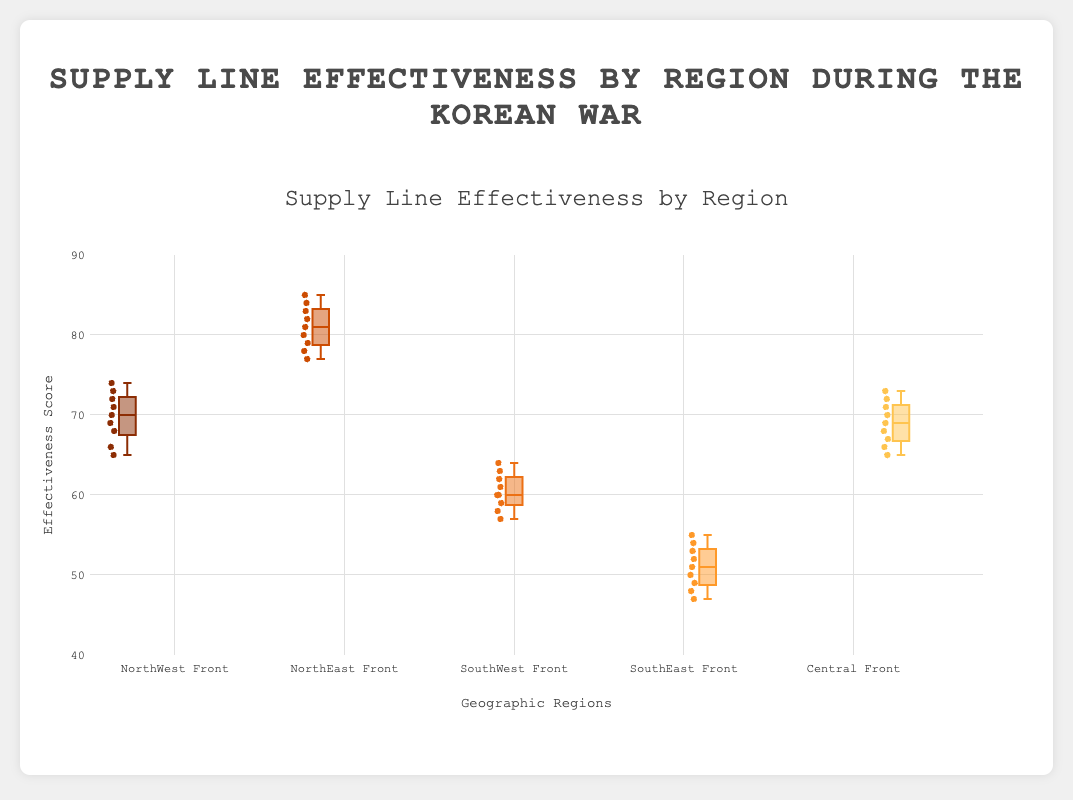What does the title of the figure indicate? The title of the figure "Supply Line Effectiveness by Region during the Korean War" indicates that the plot shows how effective the supply lines were across different geographic regions during the Korean War.
Answer: Supply Line Effectiveness by Region during the Korean War What is the range of the y-axis? The y-axis is labeled "Effectiveness Score" and ranges from 40 to 90. This range encompasses the possible effectiveness scores depicted in the box plots.
Answer: 40 to 90 Which region has the highest median supply line effectiveness? To determine which region has the highest median effectiveness, identify the horizontal line within each box representing the median. The NorthEast_Front has the highest median line of all regions.
Answer: NorthEast Front Which region has the lowest maximum supply line effectiveness? Identify the highest points, or "whiskers," of each box plot to find the maximum effectiveness for each region. The SouthEast_Front has the lowest maximum effectiveness.
Answer: SouthEast Front How does the interquartile range (IQR) compare between the NorthWest_Front and the SouthEast_Front? The IQR is the difference between the upper quartile and the lower quartile, represented by the top and bottom of the box. Comparing these, the NorthWest_Front has a much smaller IQR compared to the SouthEast_Front. The NorthWest_Front appears more consistent than the SouthEast_Front.
Answer: NorthWest Front has a smaller IQR Which region shows the greatest variability in supply line effectiveness? The region with the longest box, indicating the IQR, and possibly longer whiskers represent the greatest variability. The SouthEast_Front shows the greatest variability in effectiveness scores.
Answer: SouthEast Front What is the median effectiveness score for the Central_Front? The median is highlighted by the central line within each box. For the Central_Front, this median line lies at around 69.
Answer: 69 How many data points are there for the SouthWest_Front's supply line effectiveness? Each region's box plot includes all individual data points, which are 9 for the SouthWest_Front.
Answer: 9 Does any region have outliers in their data distribution? Outliers are data points that fall outside of the whiskers in the box plot. None of the regions have points outside the whiskers, so no region has outliers.
Answer: No Which two regions have the closest median supply line effectiveness scores? Visual inspection shows that the Central_Front and NorthWest_Front have median lines very close to each other.
Answer: Central Front and NorthWest Front 